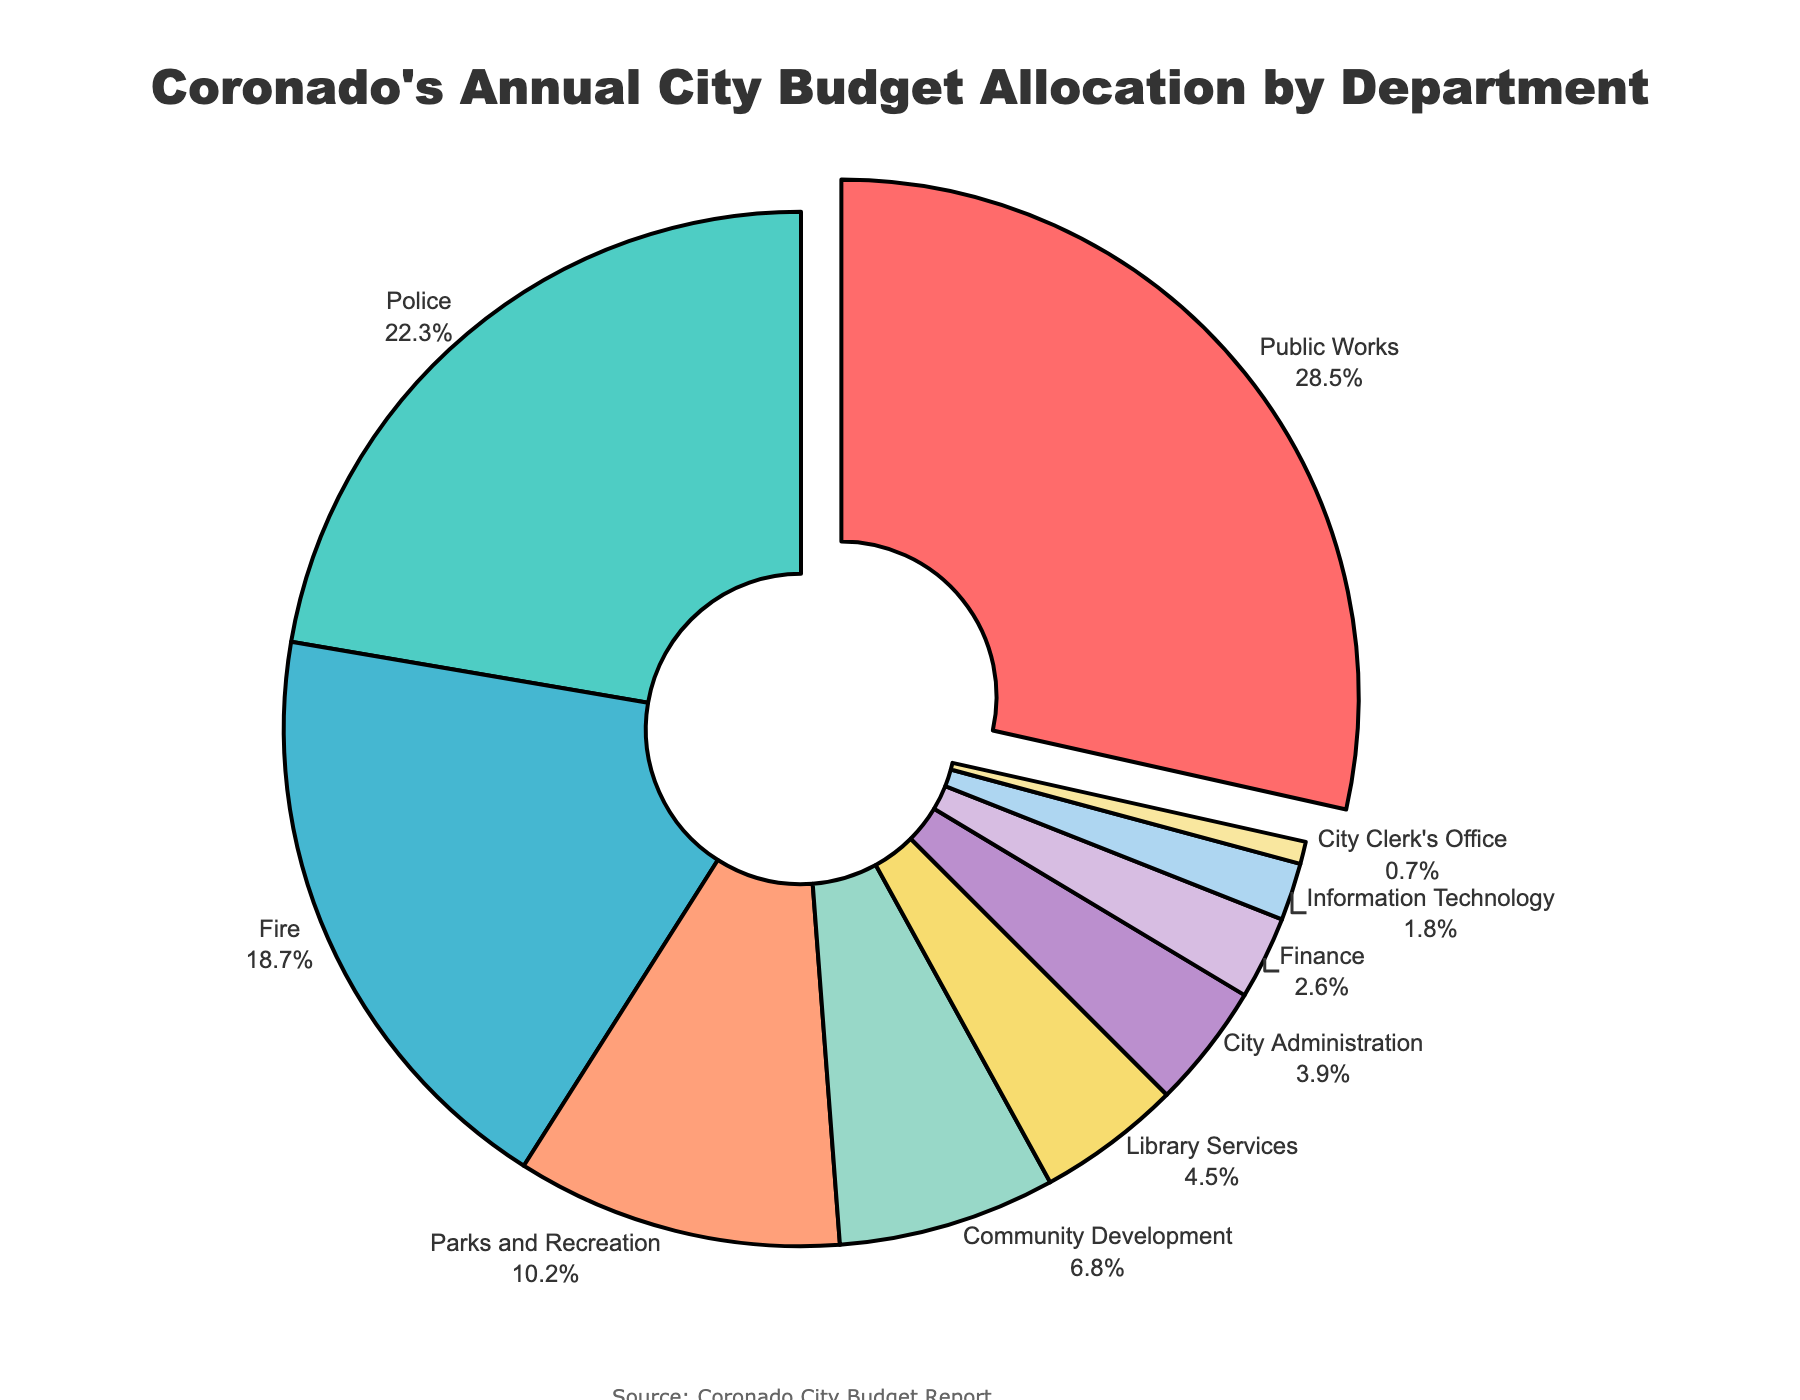What department receives the largest portion of the budget allocation? The figure shows a pie slice that is pulled out for the department with the highest allocation, which is Public Works.
Answer: Public Works How much more is allocated to the Police department than to Parks and Recreation? Police has 22.3% allocation while Parks and Recreation has 10.2%. Subtracting them gives 22.3% - 10.2% = 12.1%.
Answer: 12.1% Which departments together make up more than 50% of the budget allocation? Public Works (28.5%) and Police (22.3%) together make up 28.5% + 22.3% = 50.8%, which is more than 50%.
Answer: Public Works and Police Identify the department that has the smallest portion of the budget. The City Clerk's Office has the smallest slice in the pie chart, indicating the lowest allocation at 0.7%.
Answer: City Clerk's Office Which department receives closer to 5% of the budget allocation? Community Development (6.8%) and Library Services (4.5%) have values around 5%, but Library Services is closer.
Answer: Library Services Compare the budget allocations of Fire and Community Development departments in terms of percentage difference. Fire has 18.7% and Community Development has 6.8%. The difference in allocation is 18.7% - 6.8% = 11.9%.
Answer: 11.9% What is the combined budget allocation for Finance and Information Technology? Finance is allocated 2.6% and Information Technology 1.8%. Adding these gives 2.6% + 1.8% = 4.4%.
Answer: 4.4% Which department uses the color closest to yellow in the pie chart? The color closest to yellow is used for Library Services.
Answer: Library Services How many departments have a budget allocation above 10%? The departments with more than 10% are Public Works (28.5%), Police (22.3%), and Fire (18.7%), which totals to 3 departments.
Answer: 3 Find the department with the highest allocation and explain why it might have the largest portion. Public Works has the highest allocation at 28.5%. This department often requires significant funding for maintaining and improving infrastructure, which is essential for city functioning.
Answer: Public Works 